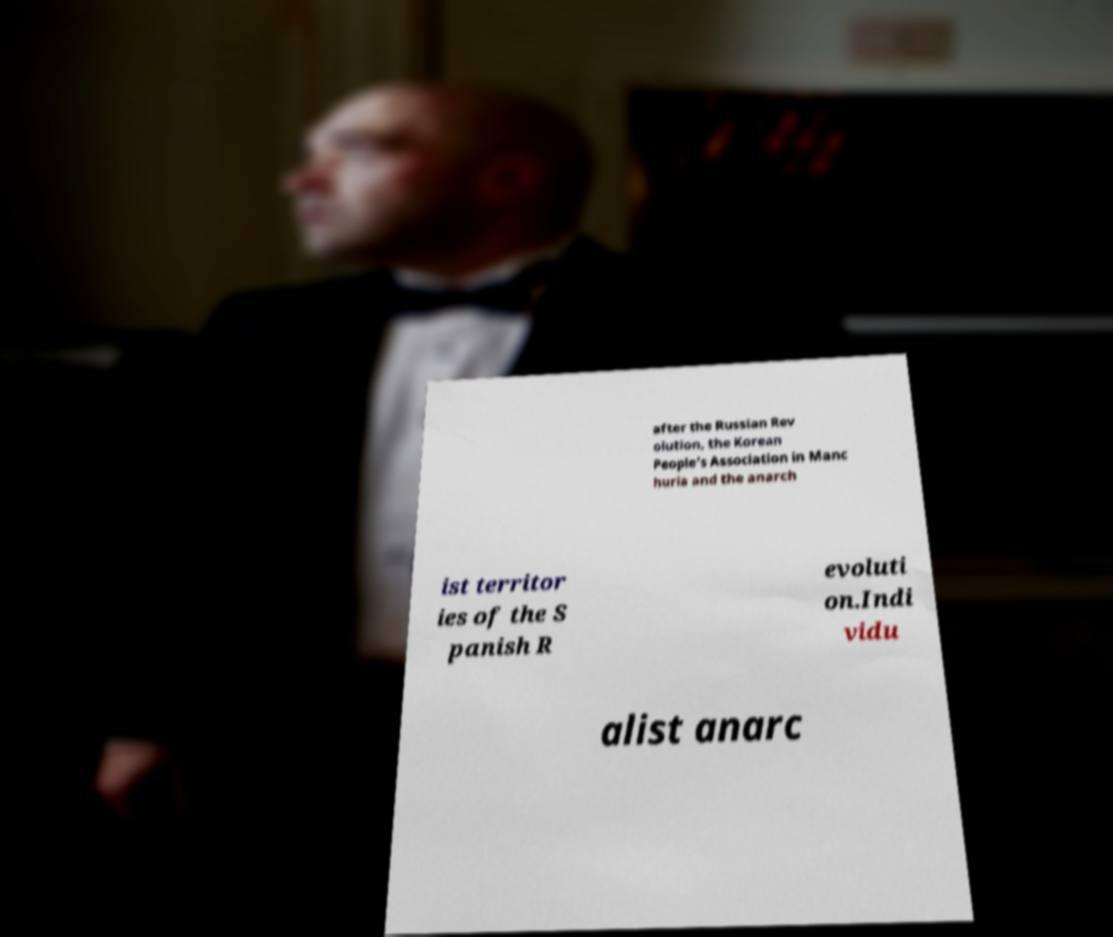Please identify and transcribe the text found in this image. after the Russian Rev olution, the Korean People's Association in Manc huria and the anarch ist territor ies of the S panish R evoluti on.Indi vidu alist anarc 